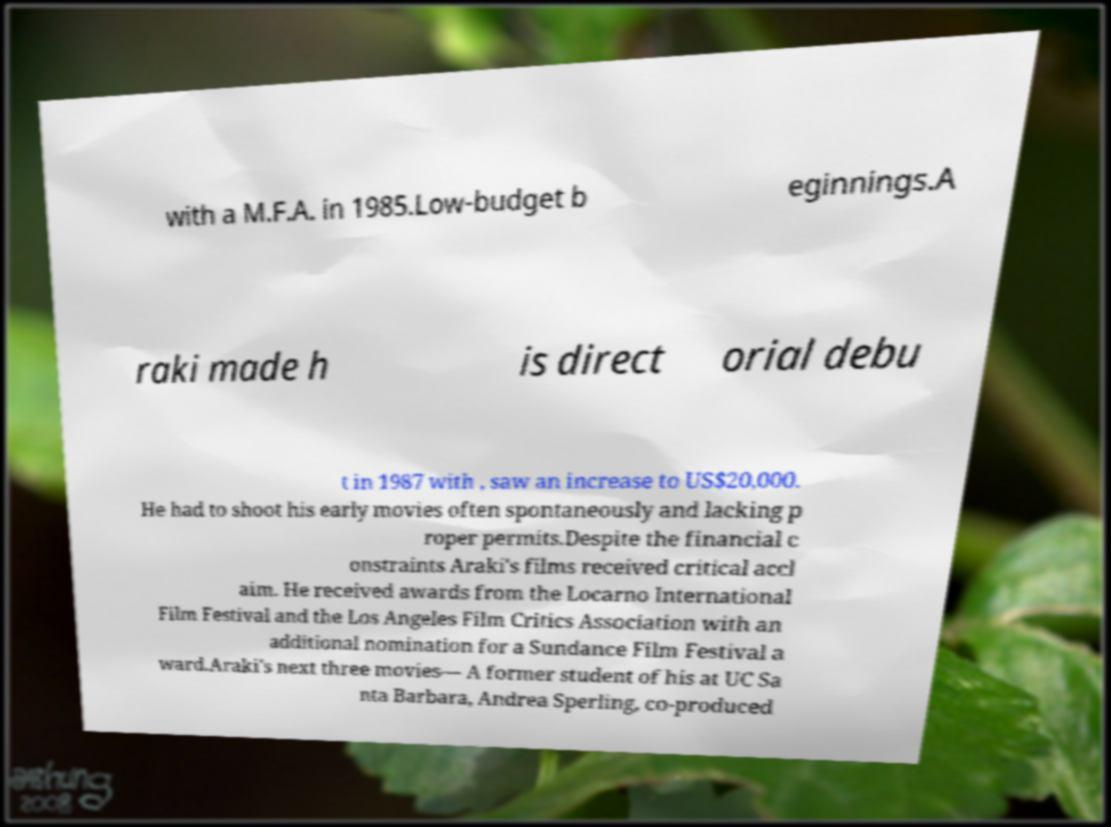Could you assist in decoding the text presented in this image and type it out clearly? with a M.F.A. in 1985.Low-budget b eginnings.A raki made h is direct orial debu t in 1987 with , saw an increase to US$20,000. He had to shoot his early movies often spontaneously and lacking p roper permits.Despite the financial c onstraints Araki's films received critical accl aim. He received awards from the Locarno International Film Festival and the Los Angeles Film Critics Association with an additional nomination for a Sundance Film Festival a ward.Araki's next three movies— A former student of his at UC Sa nta Barbara, Andrea Sperling, co-produced 